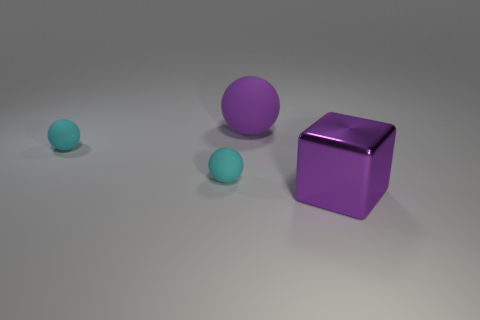What number of cyan rubber objects have the same shape as the big purple rubber thing? 2 